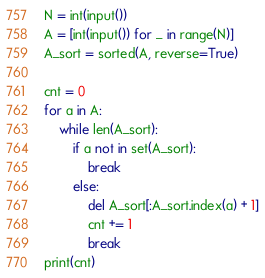<code> <loc_0><loc_0><loc_500><loc_500><_Python_>N = int(input())
A = [int(input()) for _ in range(N)]
A_sort = sorted(A, reverse=True)

cnt = 0
for a in A:
    while len(A_sort):
        if a not in set(A_sort):
            break
        else:
            del A_sort[:A_sort.index(a) + 1]
            cnt += 1
            break
print(cnt)
</code> 